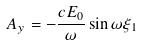<formula> <loc_0><loc_0><loc_500><loc_500>A _ { y } = - \frac { c E _ { 0 } } { \omega } \sin \omega \xi _ { 1 }</formula> 